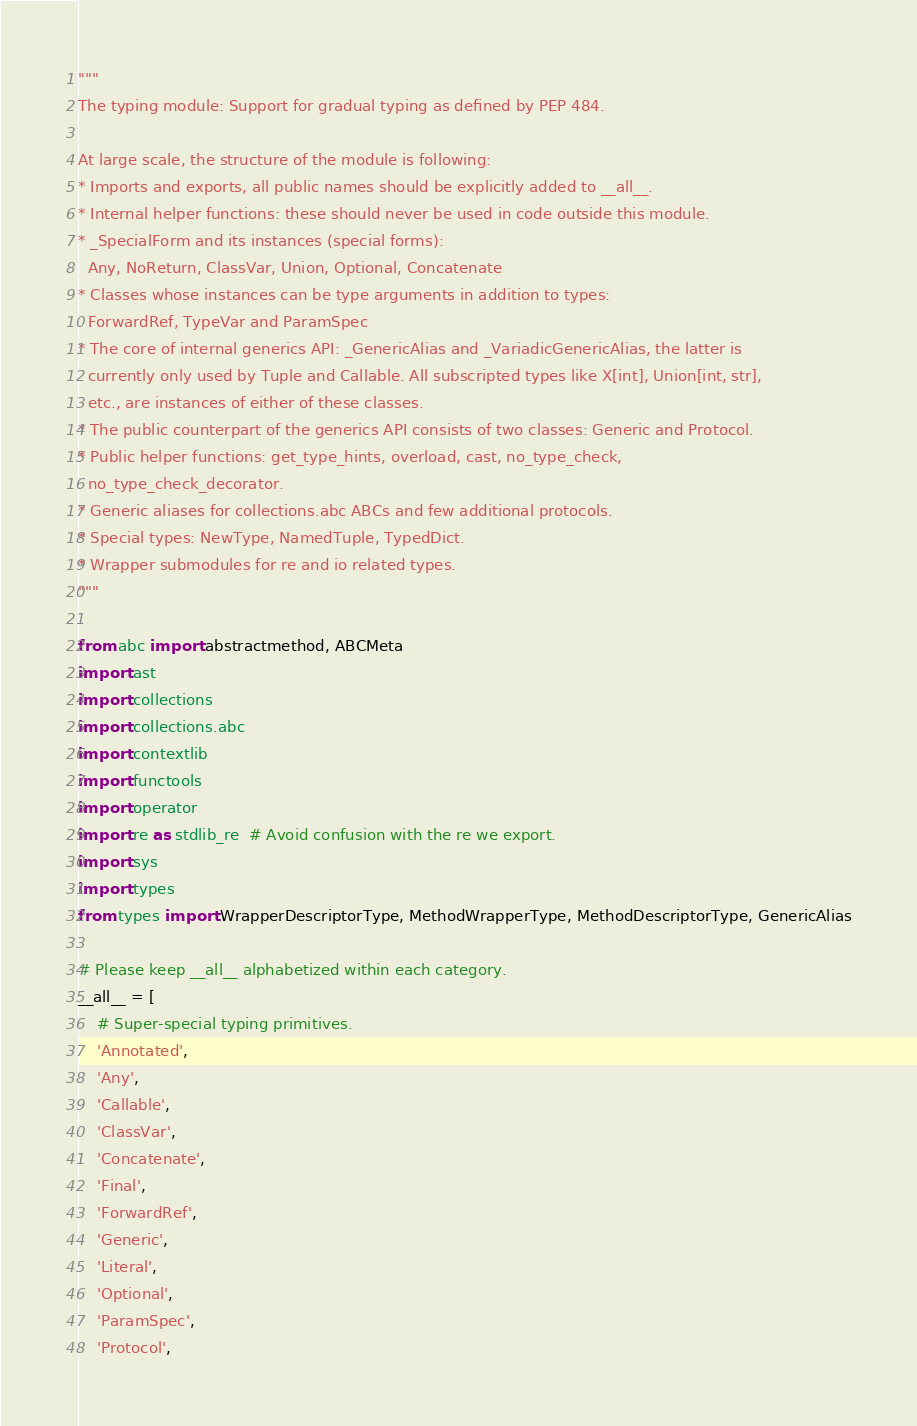Convert code to text. <code><loc_0><loc_0><loc_500><loc_500><_Python_>"""
The typing module: Support for gradual typing as defined by PEP 484.

At large scale, the structure of the module is following:
* Imports and exports, all public names should be explicitly added to __all__.
* Internal helper functions: these should never be used in code outside this module.
* _SpecialForm and its instances (special forms):
  Any, NoReturn, ClassVar, Union, Optional, Concatenate
* Classes whose instances can be type arguments in addition to types:
  ForwardRef, TypeVar and ParamSpec
* The core of internal generics API: _GenericAlias and _VariadicGenericAlias, the latter is
  currently only used by Tuple and Callable. All subscripted types like X[int], Union[int, str],
  etc., are instances of either of these classes.
* The public counterpart of the generics API consists of two classes: Generic and Protocol.
* Public helper functions: get_type_hints, overload, cast, no_type_check,
  no_type_check_decorator.
* Generic aliases for collections.abc ABCs and few additional protocols.
* Special types: NewType, NamedTuple, TypedDict.
* Wrapper submodules for re and io related types.
"""

from abc import abstractmethod, ABCMeta
import ast
import collections
import collections.abc
import contextlib
import functools
import operator
import re as stdlib_re  # Avoid confusion with the re we export.
import sys
import types
from types import WrapperDescriptorType, MethodWrapperType, MethodDescriptorType, GenericAlias

# Please keep __all__ alphabetized within each category.
__all__ = [
    # Super-special typing primitives.
    'Annotated',
    'Any',
    'Callable',
    'ClassVar',
    'Concatenate',
    'Final',
    'ForwardRef',
    'Generic',
    'Literal',
    'Optional',
    'ParamSpec',
    'Protocol',</code> 